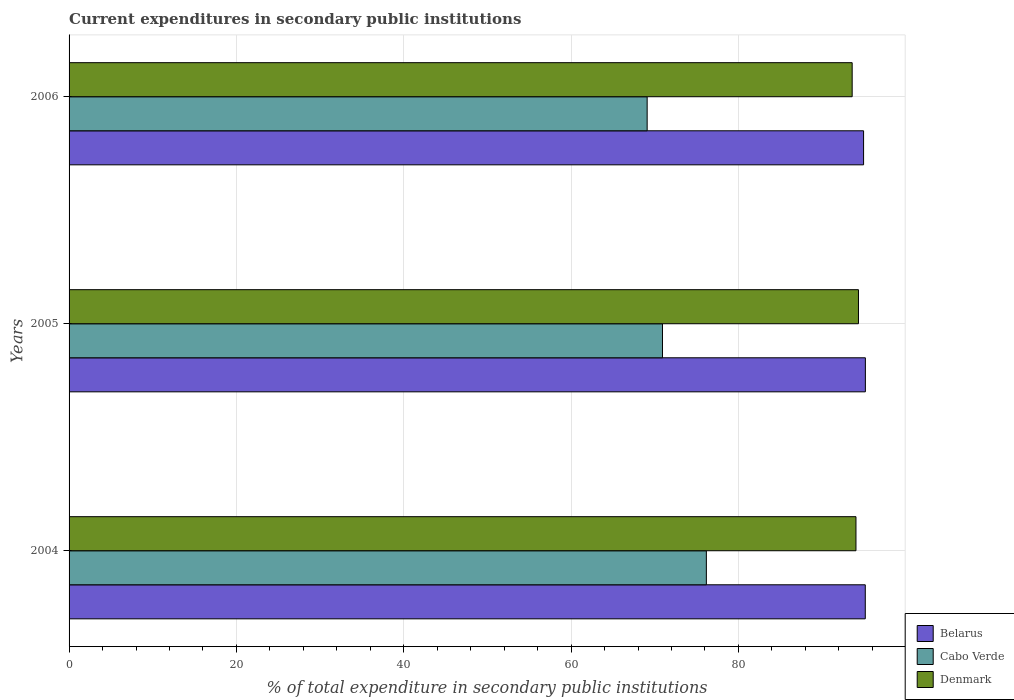Are the number of bars per tick equal to the number of legend labels?
Your response must be concise. Yes. Are the number of bars on each tick of the Y-axis equal?
Offer a terse response. Yes. What is the label of the 3rd group of bars from the top?
Your response must be concise. 2004. In how many cases, is the number of bars for a given year not equal to the number of legend labels?
Make the answer very short. 0. What is the current expenditures in secondary public institutions in Denmark in 2004?
Your answer should be very brief. 94.05. Across all years, what is the maximum current expenditures in secondary public institutions in Denmark?
Ensure brevity in your answer.  94.35. Across all years, what is the minimum current expenditures in secondary public institutions in Belarus?
Provide a succinct answer. 94.96. In which year was the current expenditures in secondary public institutions in Denmark minimum?
Your answer should be compact. 2006. What is the total current expenditures in secondary public institutions in Denmark in the graph?
Offer a terse response. 281.99. What is the difference between the current expenditures in secondary public institutions in Denmark in 2004 and that in 2006?
Your answer should be very brief. 0.45. What is the difference between the current expenditures in secondary public institutions in Cabo Verde in 2006 and the current expenditures in secondary public institutions in Belarus in 2005?
Give a very brief answer. -26.08. What is the average current expenditures in secondary public institutions in Cabo Verde per year?
Offer a terse response. 72.06. In the year 2004, what is the difference between the current expenditures in secondary public institutions in Belarus and current expenditures in secondary public institutions in Cabo Verde?
Provide a short and direct response. 18.99. What is the ratio of the current expenditures in secondary public institutions in Cabo Verde in 2004 to that in 2006?
Offer a terse response. 1.1. Is the difference between the current expenditures in secondary public institutions in Belarus in 2005 and 2006 greater than the difference between the current expenditures in secondary public institutions in Cabo Verde in 2005 and 2006?
Offer a very short reply. No. What is the difference between the highest and the second highest current expenditures in secondary public institutions in Cabo Verde?
Offer a very short reply. 5.24. What is the difference between the highest and the lowest current expenditures in secondary public institutions in Belarus?
Your response must be concise. 0.21. In how many years, is the current expenditures in secondary public institutions in Belarus greater than the average current expenditures in secondary public institutions in Belarus taken over all years?
Your answer should be very brief. 2. What does the 3rd bar from the top in 2004 represents?
Your response must be concise. Belarus. Are the values on the major ticks of X-axis written in scientific E-notation?
Make the answer very short. No. Does the graph contain any zero values?
Ensure brevity in your answer.  No. Does the graph contain grids?
Give a very brief answer. Yes. What is the title of the graph?
Give a very brief answer. Current expenditures in secondary public institutions. What is the label or title of the X-axis?
Offer a terse response. % of total expenditure in secondary public institutions. What is the % of total expenditure in secondary public institutions of Belarus in 2004?
Keep it short and to the point. 95.16. What is the % of total expenditure in secondary public institutions in Cabo Verde in 2004?
Ensure brevity in your answer.  76.17. What is the % of total expenditure in secondary public institutions in Denmark in 2004?
Provide a succinct answer. 94.05. What is the % of total expenditure in secondary public institutions of Belarus in 2005?
Your response must be concise. 95.17. What is the % of total expenditure in secondary public institutions in Cabo Verde in 2005?
Offer a very short reply. 70.92. What is the % of total expenditure in secondary public institutions in Denmark in 2005?
Keep it short and to the point. 94.35. What is the % of total expenditure in secondary public institutions of Belarus in 2006?
Make the answer very short. 94.96. What is the % of total expenditure in secondary public institutions in Cabo Verde in 2006?
Your response must be concise. 69.09. What is the % of total expenditure in secondary public institutions of Denmark in 2006?
Your answer should be very brief. 93.59. Across all years, what is the maximum % of total expenditure in secondary public institutions in Belarus?
Keep it short and to the point. 95.17. Across all years, what is the maximum % of total expenditure in secondary public institutions in Cabo Verde?
Provide a succinct answer. 76.17. Across all years, what is the maximum % of total expenditure in secondary public institutions of Denmark?
Make the answer very short. 94.35. Across all years, what is the minimum % of total expenditure in secondary public institutions in Belarus?
Your answer should be very brief. 94.96. Across all years, what is the minimum % of total expenditure in secondary public institutions of Cabo Verde?
Offer a terse response. 69.09. Across all years, what is the minimum % of total expenditure in secondary public institutions of Denmark?
Offer a very short reply. 93.59. What is the total % of total expenditure in secondary public institutions of Belarus in the graph?
Offer a terse response. 285.29. What is the total % of total expenditure in secondary public institutions in Cabo Verde in the graph?
Provide a short and direct response. 216.18. What is the total % of total expenditure in secondary public institutions of Denmark in the graph?
Provide a succinct answer. 281.99. What is the difference between the % of total expenditure in secondary public institutions in Belarus in 2004 and that in 2005?
Provide a short and direct response. -0.01. What is the difference between the % of total expenditure in secondary public institutions of Cabo Verde in 2004 and that in 2005?
Provide a short and direct response. 5.24. What is the difference between the % of total expenditure in secondary public institutions of Denmark in 2004 and that in 2005?
Ensure brevity in your answer.  -0.3. What is the difference between the % of total expenditure in secondary public institutions in Belarus in 2004 and that in 2006?
Provide a short and direct response. 0.2. What is the difference between the % of total expenditure in secondary public institutions of Cabo Verde in 2004 and that in 2006?
Offer a very short reply. 7.08. What is the difference between the % of total expenditure in secondary public institutions of Denmark in 2004 and that in 2006?
Give a very brief answer. 0.45. What is the difference between the % of total expenditure in secondary public institutions in Belarus in 2005 and that in 2006?
Ensure brevity in your answer.  0.21. What is the difference between the % of total expenditure in secondary public institutions of Cabo Verde in 2005 and that in 2006?
Your answer should be compact. 1.83. What is the difference between the % of total expenditure in secondary public institutions of Denmark in 2005 and that in 2006?
Ensure brevity in your answer.  0.75. What is the difference between the % of total expenditure in secondary public institutions in Belarus in 2004 and the % of total expenditure in secondary public institutions in Cabo Verde in 2005?
Your answer should be compact. 24.24. What is the difference between the % of total expenditure in secondary public institutions in Belarus in 2004 and the % of total expenditure in secondary public institutions in Denmark in 2005?
Give a very brief answer. 0.81. What is the difference between the % of total expenditure in secondary public institutions in Cabo Verde in 2004 and the % of total expenditure in secondary public institutions in Denmark in 2005?
Provide a succinct answer. -18.18. What is the difference between the % of total expenditure in secondary public institutions in Belarus in 2004 and the % of total expenditure in secondary public institutions in Cabo Verde in 2006?
Keep it short and to the point. 26.07. What is the difference between the % of total expenditure in secondary public institutions of Belarus in 2004 and the % of total expenditure in secondary public institutions of Denmark in 2006?
Offer a terse response. 1.57. What is the difference between the % of total expenditure in secondary public institutions in Cabo Verde in 2004 and the % of total expenditure in secondary public institutions in Denmark in 2006?
Make the answer very short. -17.43. What is the difference between the % of total expenditure in secondary public institutions of Belarus in 2005 and the % of total expenditure in secondary public institutions of Cabo Verde in 2006?
Offer a terse response. 26.08. What is the difference between the % of total expenditure in secondary public institutions in Belarus in 2005 and the % of total expenditure in secondary public institutions in Denmark in 2006?
Provide a succinct answer. 1.58. What is the difference between the % of total expenditure in secondary public institutions of Cabo Verde in 2005 and the % of total expenditure in secondary public institutions of Denmark in 2006?
Offer a terse response. -22.67. What is the average % of total expenditure in secondary public institutions in Belarus per year?
Keep it short and to the point. 95.1. What is the average % of total expenditure in secondary public institutions of Cabo Verde per year?
Keep it short and to the point. 72.06. What is the average % of total expenditure in secondary public institutions in Denmark per year?
Give a very brief answer. 94. In the year 2004, what is the difference between the % of total expenditure in secondary public institutions in Belarus and % of total expenditure in secondary public institutions in Cabo Verde?
Make the answer very short. 18.99. In the year 2004, what is the difference between the % of total expenditure in secondary public institutions of Belarus and % of total expenditure in secondary public institutions of Denmark?
Your response must be concise. 1.11. In the year 2004, what is the difference between the % of total expenditure in secondary public institutions in Cabo Verde and % of total expenditure in secondary public institutions in Denmark?
Your answer should be compact. -17.88. In the year 2005, what is the difference between the % of total expenditure in secondary public institutions in Belarus and % of total expenditure in secondary public institutions in Cabo Verde?
Your answer should be compact. 24.25. In the year 2005, what is the difference between the % of total expenditure in secondary public institutions of Belarus and % of total expenditure in secondary public institutions of Denmark?
Keep it short and to the point. 0.83. In the year 2005, what is the difference between the % of total expenditure in secondary public institutions of Cabo Verde and % of total expenditure in secondary public institutions of Denmark?
Your response must be concise. -23.42. In the year 2006, what is the difference between the % of total expenditure in secondary public institutions in Belarus and % of total expenditure in secondary public institutions in Cabo Verde?
Your answer should be compact. 25.87. In the year 2006, what is the difference between the % of total expenditure in secondary public institutions of Belarus and % of total expenditure in secondary public institutions of Denmark?
Keep it short and to the point. 1.36. In the year 2006, what is the difference between the % of total expenditure in secondary public institutions in Cabo Verde and % of total expenditure in secondary public institutions in Denmark?
Your answer should be compact. -24.5. What is the ratio of the % of total expenditure in secondary public institutions in Belarus in 2004 to that in 2005?
Provide a succinct answer. 1. What is the ratio of the % of total expenditure in secondary public institutions in Cabo Verde in 2004 to that in 2005?
Offer a very short reply. 1.07. What is the ratio of the % of total expenditure in secondary public institutions of Denmark in 2004 to that in 2005?
Your answer should be compact. 1. What is the ratio of the % of total expenditure in secondary public institutions of Cabo Verde in 2004 to that in 2006?
Keep it short and to the point. 1.1. What is the ratio of the % of total expenditure in secondary public institutions in Belarus in 2005 to that in 2006?
Offer a terse response. 1. What is the ratio of the % of total expenditure in secondary public institutions of Cabo Verde in 2005 to that in 2006?
Offer a very short reply. 1.03. What is the ratio of the % of total expenditure in secondary public institutions in Denmark in 2005 to that in 2006?
Your answer should be very brief. 1.01. What is the difference between the highest and the second highest % of total expenditure in secondary public institutions in Belarus?
Provide a short and direct response. 0.01. What is the difference between the highest and the second highest % of total expenditure in secondary public institutions in Cabo Verde?
Offer a very short reply. 5.24. What is the difference between the highest and the second highest % of total expenditure in secondary public institutions of Denmark?
Provide a short and direct response. 0.3. What is the difference between the highest and the lowest % of total expenditure in secondary public institutions of Belarus?
Offer a very short reply. 0.21. What is the difference between the highest and the lowest % of total expenditure in secondary public institutions in Cabo Verde?
Give a very brief answer. 7.08. What is the difference between the highest and the lowest % of total expenditure in secondary public institutions of Denmark?
Provide a succinct answer. 0.75. 